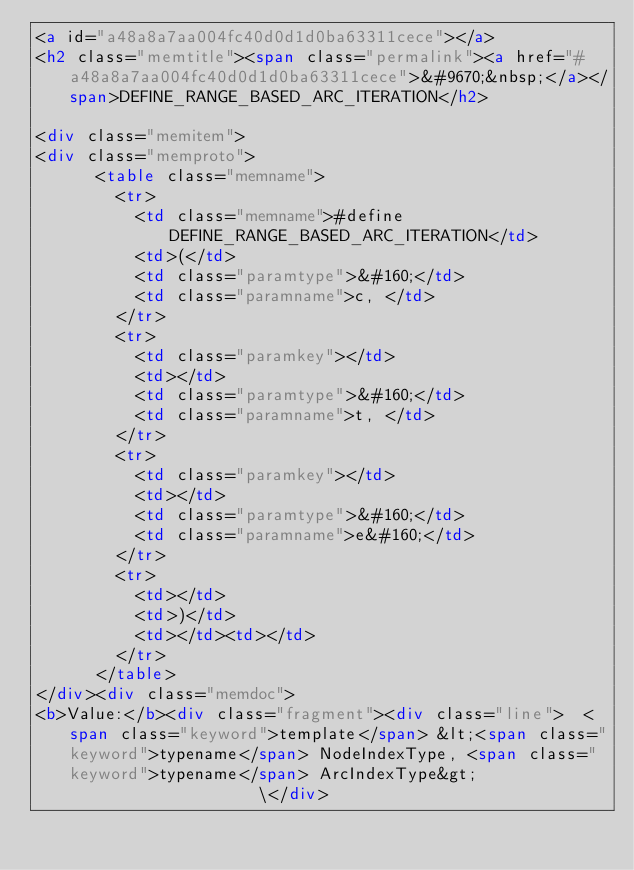<code> <loc_0><loc_0><loc_500><loc_500><_HTML_><a id="a48a8a7aa004fc40d0d1d0ba63311cece"></a>
<h2 class="memtitle"><span class="permalink"><a href="#a48a8a7aa004fc40d0d1d0ba63311cece">&#9670;&nbsp;</a></span>DEFINE_RANGE_BASED_ARC_ITERATION</h2>

<div class="memitem">
<div class="memproto">
      <table class="memname">
        <tr>
          <td class="memname">#define DEFINE_RANGE_BASED_ARC_ITERATION</td>
          <td>(</td>
          <td class="paramtype">&#160;</td>
          <td class="paramname">c, </td>
        </tr>
        <tr>
          <td class="paramkey"></td>
          <td></td>
          <td class="paramtype">&#160;</td>
          <td class="paramname">t, </td>
        </tr>
        <tr>
          <td class="paramkey"></td>
          <td></td>
          <td class="paramtype">&#160;</td>
          <td class="paramname">e&#160;</td>
        </tr>
        <tr>
          <td></td>
          <td>)</td>
          <td></td><td></td>
        </tr>
      </table>
</div><div class="memdoc">
<b>Value:</b><div class="fragment"><div class="line">  <span class="keyword">template</span> &lt;<span class="keyword">typename</span> NodeIndexType, <span class="keyword">typename</span> ArcIndexType&gt;                    \</div></code> 